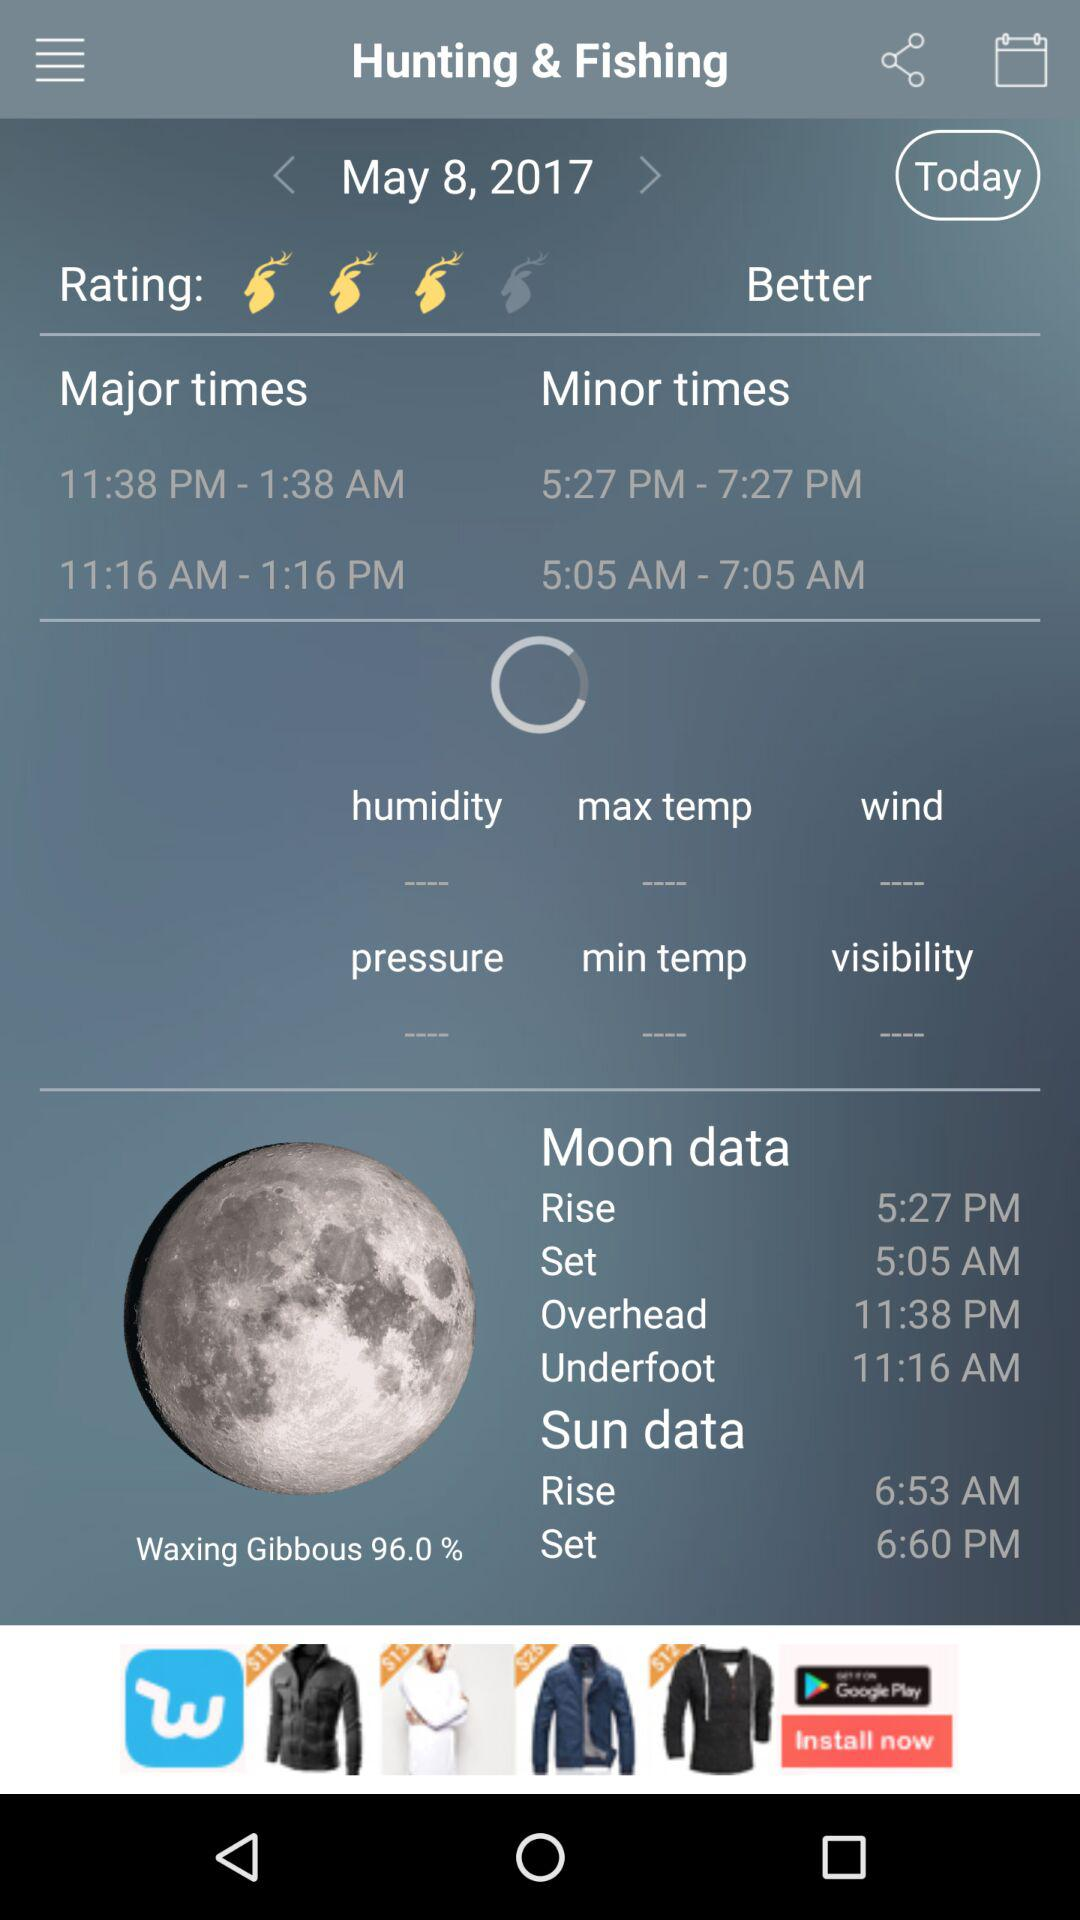What is the date? The date is May 8, 2017. 